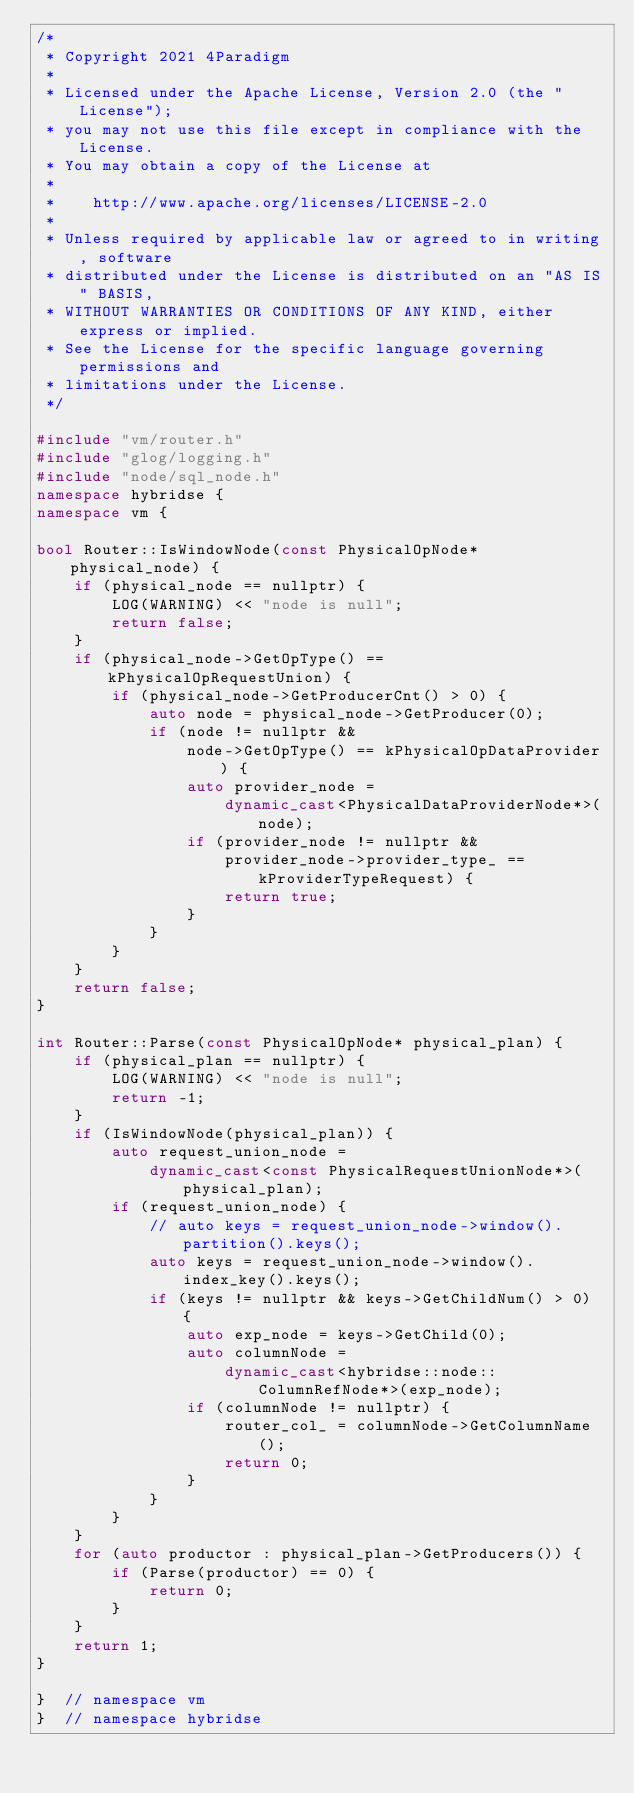<code> <loc_0><loc_0><loc_500><loc_500><_C++_>/*
 * Copyright 2021 4Paradigm
 *
 * Licensed under the Apache License, Version 2.0 (the "License");
 * you may not use this file except in compliance with the License.
 * You may obtain a copy of the License at
 *
 *    http://www.apache.org/licenses/LICENSE-2.0
 *
 * Unless required by applicable law or agreed to in writing, software
 * distributed under the License is distributed on an "AS IS" BASIS,
 * WITHOUT WARRANTIES OR CONDITIONS OF ANY KIND, either express or implied.
 * See the License for the specific language governing permissions and
 * limitations under the License.
 */

#include "vm/router.h"
#include "glog/logging.h"
#include "node/sql_node.h"
namespace hybridse {
namespace vm {

bool Router::IsWindowNode(const PhysicalOpNode* physical_node) {
    if (physical_node == nullptr) {
        LOG(WARNING) << "node is null";
        return false;
    }
    if (physical_node->GetOpType() == kPhysicalOpRequestUnion) {
        if (physical_node->GetProducerCnt() > 0) {
            auto node = physical_node->GetProducer(0);
            if (node != nullptr &&
                node->GetOpType() == kPhysicalOpDataProvider) {
                auto provider_node =
                    dynamic_cast<PhysicalDataProviderNode*>(node);
                if (provider_node != nullptr &&
                    provider_node->provider_type_ == kProviderTypeRequest) {
                    return true;
                }
            }
        }
    }
    return false;
}

int Router::Parse(const PhysicalOpNode* physical_plan) {
    if (physical_plan == nullptr) {
        LOG(WARNING) << "node is null";
        return -1;
    }
    if (IsWindowNode(physical_plan)) {
        auto request_union_node =
            dynamic_cast<const PhysicalRequestUnionNode*>(physical_plan);
        if (request_union_node) {
            // auto keys = request_union_node->window().partition().keys();
            auto keys = request_union_node->window().index_key().keys();
            if (keys != nullptr && keys->GetChildNum() > 0) {
                auto exp_node = keys->GetChild(0);
                auto columnNode =
                    dynamic_cast<hybridse::node::ColumnRefNode*>(exp_node);
                if (columnNode != nullptr) {
                    router_col_ = columnNode->GetColumnName();
                    return 0;
                }
            }
        }
    }
    for (auto productor : physical_plan->GetProducers()) {
        if (Parse(productor) == 0) {
            return 0;
        }
    }
    return 1;
}

}  // namespace vm
}  // namespace hybridse
</code> 